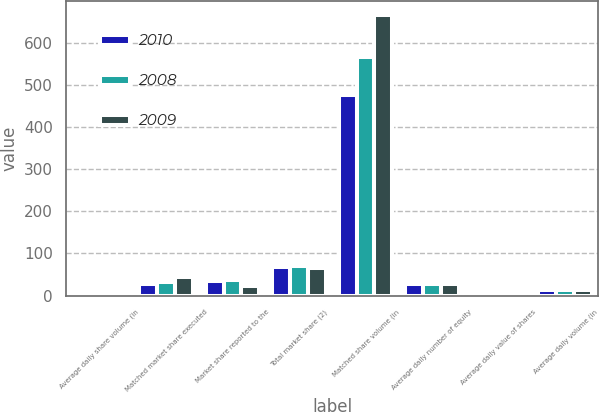<chart> <loc_0><loc_0><loc_500><loc_500><stacked_bar_chart><ecel><fcel>Average daily share volume (in<fcel>Matched market share executed<fcel>Market share reported to the<fcel>Total market share (2)<fcel>Matched share volume (in<fcel>Average daily number of equity<fcel>Average daily value of shares<fcel>Average daily volume (in<nl><fcel>2010<fcel>2.19<fcel>28.6<fcel>35.5<fcel>67.1<fcel>475<fcel>28.6<fcel>3.3<fcel>14.3<nl><fcel>2008<fcel>2.24<fcel>33<fcel>36.6<fcel>71<fcel>566.6<fcel>28.6<fcel>3.1<fcel>13.4<nl><fcel>2009<fcel>2.28<fcel>43.2<fcel>22.6<fcel>65.8<fcel>665.9<fcel>28.6<fcel>5<fcel>13<nl></chart> 